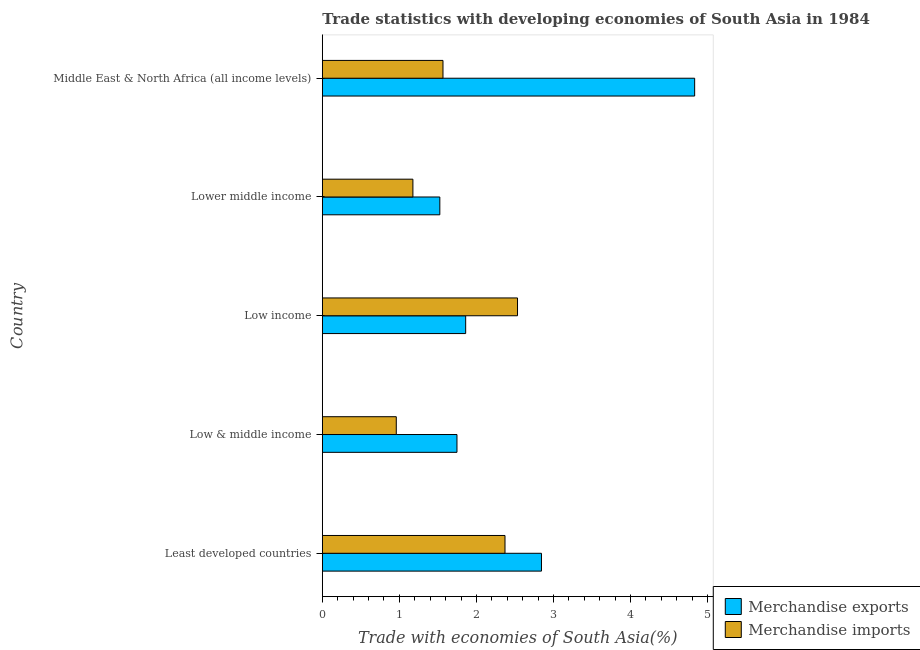How many different coloured bars are there?
Provide a succinct answer. 2. What is the label of the 1st group of bars from the top?
Your response must be concise. Middle East & North Africa (all income levels). In how many cases, is the number of bars for a given country not equal to the number of legend labels?
Make the answer very short. 0. What is the merchandise imports in Least developed countries?
Your answer should be very brief. 2.37. Across all countries, what is the maximum merchandise exports?
Your answer should be compact. 4.83. Across all countries, what is the minimum merchandise imports?
Your answer should be very brief. 0.96. In which country was the merchandise exports maximum?
Give a very brief answer. Middle East & North Africa (all income levels). In which country was the merchandise exports minimum?
Give a very brief answer. Lower middle income. What is the total merchandise imports in the graph?
Give a very brief answer. 8.6. What is the difference between the merchandise imports in Low & middle income and the merchandise exports in Least developed countries?
Keep it short and to the point. -1.88. What is the average merchandise imports per country?
Provide a short and direct response. 1.72. What is the difference between the merchandise exports and merchandise imports in Middle East & North Africa (all income levels)?
Your answer should be very brief. 3.27. What is the ratio of the merchandise exports in Low & middle income to that in Middle East & North Africa (all income levels)?
Offer a terse response. 0.36. Is the merchandise exports in Lower middle income less than that in Middle East & North Africa (all income levels)?
Your answer should be compact. Yes. Is the difference between the merchandise exports in Least developed countries and Middle East & North Africa (all income levels) greater than the difference between the merchandise imports in Least developed countries and Middle East & North Africa (all income levels)?
Provide a short and direct response. No. What is the difference between the highest and the second highest merchandise exports?
Your answer should be very brief. 1.99. What is the difference between the highest and the lowest merchandise imports?
Offer a terse response. 1.57. In how many countries, is the merchandise imports greater than the average merchandise imports taken over all countries?
Your answer should be very brief. 2. What does the 2nd bar from the top in Lower middle income represents?
Offer a terse response. Merchandise exports. What does the 2nd bar from the bottom in Middle East & North Africa (all income levels) represents?
Your response must be concise. Merchandise imports. How many bars are there?
Make the answer very short. 10. Are all the bars in the graph horizontal?
Your answer should be compact. Yes. What is the difference between two consecutive major ticks on the X-axis?
Offer a very short reply. 1. Does the graph contain grids?
Your answer should be compact. No. How many legend labels are there?
Your answer should be very brief. 2. What is the title of the graph?
Give a very brief answer. Trade statistics with developing economies of South Asia in 1984. Does "Unregistered firms" appear as one of the legend labels in the graph?
Your response must be concise. No. What is the label or title of the X-axis?
Give a very brief answer. Trade with economies of South Asia(%). What is the label or title of the Y-axis?
Make the answer very short. Country. What is the Trade with economies of South Asia(%) in Merchandise exports in Least developed countries?
Your response must be concise. 2.84. What is the Trade with economies of South Asia(%) of Merchandise imports in Least developed countries?
Give a very brief answer. 2.37. What is the Trade with economies of South Asia(%) in Merchandise exports in Low & middle income?
Provide a succinct answer. 1.75. What is the Trade with economies of South Asia(%) of Merchandise imports in Low & middle income?
Give a very brief answer. 0.96. What is the Trade with economies of South Asia(%) in Merchandise exports in Low income?
Your answer should be compact. 1.86. What is the Trade with economies of South Asia(%) of Merchandise imports in Low income?
Ensure brevity in your answer.  2.53. What is the Trade with economies of South Asia(%) in Merchandise exports in Lower middle income?
Your response must be concise. 1.52. What is the Trade with economies of South Asia(%) of Merchandise imports in Lower middle income?
Give a very brief answer. 1.18. What is the Trade with economies of South Asia(%) of Merchandise exports in Middle East & North Africa (all income levels)?
Your answer should be compact. 4.83. What is the Trade with economies of South Asia(%) of Merchandise imports in Middle East & North Africa (all income levels)?
Keep it short and to the point. 1.57. Across all countries, what is the maximum Trade with economies of South Asia(%) in Merchandise exports?
Provide a short and direct response. 4.83. Across all countries, what is the maximum Trade with economies of South Asia(%) of Merchandise imports?
Your response must be concise. 2.53. Across all countries, what is the minimum Trade with economies of South Asia(%) in Merchandise exports?
Provide a succinct answer. 1.52. Across all countries, what is the minimum Trade with economies of South Asia(%) in Merchandise imports?
Ensure brevity in your answer.  0.96. What is the total Trade with economies of South Asia(%) in Merchandise exports in the graph?
Ensure brevity in your answer.  12.81. What is the total Trade with economies of South Asia(%) of Merchandise imports in the graph?
Your response must be concise. 8.6. What is the difference between the Trade with economies of South Asia(%) in Merchandise exports in Least developed countries and that in Low & middle income?
Your answer should be very brief. 1.1. What is the difference between the Trade with economies of South Asia(%) in Merchandise imports in Least developed countries and that in Low & middle income?
Your answer should be very brief. 1.41. What is the difference between the Trade with economies of South Asia(%) of Merchandise exports in Least developed countries and that in Low income?
Offer a very short reply. 0.98. What is the difference between the Trade with economies of South Asia(%) in Merchandise imports in Least developed countries and that in Low income?
Your answer should be very brief. -0.16. What is the difference between the Trade with economies of South Asia(%) in Merchandise exports in Least developed countries and that in Lower middle income?
Your answer should be very brief. 1.32. What is the difference between the Trade with economies of South Asia(%) of Merchandise imports in Least developed countries and that in Lower middle income?
Your response must be concise. 1.2. What is the difference between the Trade with economies of South Asia(%) in Merchandise exports in Least developed countries and that in Middle East & North Africa (all income levels)?
Ensure brevity in your answer.  -1.99. What is the difference between the Trade with economies of South Asia(%) of Merchandise imports in Least developed countries and that in Middle East & North Africa (all income levels)?
Give a very brief answer. 0.8. What is the difference between the Trade with economies of South Asia(%) in Merchandise exports in Low & middle income and that in Low income?
Ensure brevity in your answer.  -0.11. What is the difference between the Trade with economies of South Asia(%) in Merchandise imports in Low & middle income and that in Low income?
Provide a short and direct response. -1.57. What is the difference between the Trade with economies of South Asia(%) of Merchandise exports in Low & middle income and that in Lower middle income?
Your answer should be very brief. 0.22. What is the difference between the Trade with economies of South Asia(%) of Merchandise imports in Low & middle income and that in Lower middle income?
Ensure brevity in your answer.  -0.22. What is the difference between the Trade with economies of South Asia(%) of Merchandise exports in Low & middle income and that in Middle East & North Africa (all income levels)?
Offer a terse response. -3.08. What is the difference between the Trade with economies of South Asia(%) of Merchandise imports in Low & middle income and that in Middle East & North Africa (all income levels)?
Ensure brevity in your answer.  -0.61. What is the difference between the Trade with economies of South Asia(%) of Merchandise exports in Low income and that in Lower middle income?
Make the answer very short. 0.34. What is the difference between the Trade with economies of South Asia(%) of Merchandise imports in Low income and that in Lower middle income?
Provide a succinct answer. 1.36. What is the difference between the Trade with economies of South Asia(%) of Merchandise exports in Low income and that in Middle East & North Africa (all income levels)?
Give a very brief answer. -2.97. What is the difference between the Trade with economies of South Asia(%) of Merchandise imports in Low income and that in Middle East & North Africa (all income levels)?
Offer a terse response. 0.97. What is the difference between the Trade with economies of South Asia(%) of Merchandise exports in Lower middle income and that in Middle East & North Africa (all income levels)?
Offer a terse response. -3.31. What is the difference between the Trade with economies of South Asia(%) of Merchandise imports in Lower middle income and that in Middle East & North Africa (all income levels)?
Ensure brevity in your answer.  -0.39. What is the difference between the Trade with economies of South Asia(%) of Merchandise exports in Least developed countries and the Trade with economies of South Asia(%) of Merchandise imports in Low & middle income?
Your answer should be compact. 1.88. What is the difference between the Trade with economies of South Asia(%) of Merchandise exports in Least developed countries and the Trade with economies of South Asia(%) of Merchandise imports in Low income?
Provide a short and direct response. 0.31. What is the difference between the Trade with economies of South Asia(%) of Merchandise exports in Least developed countries and the Trade with economies of South Asia(%) of Merchandise imports in Lower middle income?
Offer a terse response. 1.67. What is the difference between the Trade with economies of South Asia(%) in Merchandise exports in Least developed countries and the Trade with economies of South Asia(%) in Merchandise imports in Middle East & North Africa (all income levels)?
Provide a short and direct response. 1.28. What is the difference between the Trade with economies of South Asia(%) of Merchandise exports in Low & middle income and the Trade with economies of South Asia(%) of Merchandise imports in Low income?
Your answer should be compact. -0.79. What is the difference between the Trade with economies of South Asia(%) in Merchandise exports in Low & middle income and the Trade with economies of South Asia(%) in Merchandise imports in Lower middle income?
Provide a short and direct response. 0.57. What is the difference between the Trade with economies of South Asia(%) in Merchandise exports in Low & middle income and the Trade with economies of South Asia(%) in Merchandise imports in Middle East & North Africa (all income levels)?
Offer a very short reply. 0.18. What is the difference between the Trade with economies of South Asia(%) in Merchandise exports in Low income and the Trade with economies of South Asia(%) in Merchandise imports in Lower middle income?
Your answer should be compact. 0.68. What is the difference between the Trade with economies of South Asia(%) of Merchandise exports in Low income and the Trade with economies of South Asia(%) of Merchandise imports in Middle East & North Africa (all income levels)?
Provide a succinct answer. 0.29. What is the difference between the Trade with economies of South Asia(%) of Merchandise exports in Lower middle income and the Trade with economies of South Asia(%) of Merchandise imports in Middle East & North Africa (all income levels)?
Your answer should be very brief. -0.04. What is the average Trade with economies of South Asia(%) in Merchandise exports per country?
Your answer should be very brief. 2.56. What is the average Trade with economies of South Asia(%) in Merchandise imports per country?
Provide a short and direct response. 1.72. What is the difference between the Trade with economies of South Asia(%) of Merchandise exports and Trade with economies of South Asia(%) of Merchandise imports in Least developed countries?
Provide a short and direct response. 0.47. What is the difference between the Trade with economies of South Asia(%) in Merchandise exports and Trade with economies of South Asia(%) in Merchandise imports in Low & middle income?
Make the answer very short. 0.79. What is the difference between the Trade with economies of South Asia(%) of Merchandise exports and Trade with economies of South Asia(%) of Merchandise imports in Low income?
Offer a very short reply. -0.67. What is the difference between the Trade with economies of South Asia(%) of Merchandise exports and Trade with economies of South Asia(%) of Merchandise imports in Lower middle income?
Give a very brief answer. 0.35. What is the difference between the Trade with economies of South Asia(%) of Merchandise exports and Trade with economies of South Asia(%) of Merchandise imports in Middle East & North Africa (all income levels)?
Offer a terse response. 3.27. What is the ratio of the Trade with economies of South Asia(%) in Merchandise exports in Least developed countries to that in Low & middle income?
Keep it short and to the point. 1.63. What is the ratio of the Trade with economies of South Asia(%) of Merchandise imports in Least developed countries to that in Low & middle income?
Give a very brief answer. 2.47. What is the ratio of the Trade with economies of South Asia(%) in Merchandise exports in Least developed countries to that in Low income?
Your answer should be very brief. 1.53. What is the ratio of the Trade with economies of South Asia(%) of Merchandise imports in Least developed countries to that in Low income?
Ensure brevity in your answer.  0.94. What is the ratio of the Trade with economies of South Asia(%) in Merchandise exports in Least developed countries to that in Lower middle income?
Your response must be concise. 1.87. What is the ratio of the Trade with economies of South Asia(%) of Merchandise imports in Least developed countries to that in Lower middle income?
Provide a short and direct response. 2.02. What is the ratio of the Trade with economies of South Asia(%) of Merchandise exports in Least developed countries to that in Middle East & North Africa (all income levels)?
Your response must be concise. 0.59. What is the ratio of the Trade with economies of South Asia(%) in Merchandise imports in Least developed countries to that in Middle East & North Africa (all income levels)?
Offer a terse response. 1.51. What is the ratio of the Trade with economies of South Asia(%) in Merchandise exports in Low & middle income to that in Low income?
Your response must be concise. 0.94. What is the ratio of the Trade with economies of South Asia(%) in Merchandise imports in Low & middle income to that in Low income?
Offer a very short reply. 0.38. What is the ratio of the Trade with economies of South Asia(%) in Merchandise exports in Low & middle income to that in Lower middle income?
Your answer should be compact. 1.15. What is the ratio of the Trade with economies of South Asia(%) in Merchandise imports in Low & middle income to that in Lower middle income?
Provide a succinct answer. 0.82. What is the ratio of the Trade with economies of South Asia(%) of Merchandise exports in Low & middle income to that in Middle East & North Africa (all income levels)?
Offer a very short reply. 0.36. What is the ratio of the Trade with economies of South Asia(%) in Merchandise imports in Low & middle income to that in Middle East & North Africa (all income levels)?
Keep it short and to the point. 0.61. What is the ratio of the Trade with economies of South Asia(%) in Merchandise exports in Low income to that in Lower middle income?
Ensure brevity in your answer.  1.22. What is the ratio of the Trade with economies of South Asia(%) in Merchandise imports in Low income to that in Lower middle income?
Your answer should be very brief. 2.16. What is the ratio of the Trade with economies of South Asia(%) of Merchandise exports in Low income to that in Middle East & North Africa (all income levels)?
Make the answer very short. 0.39. What is the ratio of the Trade with economies of South Asia(%) in Merchandise imports in Low income to that in Middle East & North Africa (all income levels)?
Provide a succinct answer. 1.62. What is the ratio of the Trade with economies of South Asia(%) in Merchandise exports in Lower middle income to that in Middle East & North Africa (all income levels)?
Ensure brevity in your answer.  0.32. What is the ratio of the Trade with economies of South Asia(%) in Merchandise imports in Lower middle income to that in Middle East & North Africa (all income levels)?
Your answer should be compact. 0.75. What is the difference between the highest and the second highest Trade with economies of South Asia(%) of Merchandise exports?
Your answer should be very brief. 1.99. What is the difference between the highest and the second highest Trade with economies of South Asia(%) in Merchandise imports?
Give a very brief answer. 0.16. What is the difference between the highest and the lowest Trade with economies of South Asia(%) in Merchandise exports?
Offer a very short reply. 3.31. What is the difference between the highest and the lowest Trade with economies of South Asia(%) of Merchandise imports?
Ensure brevity in your answer.  1.57. 